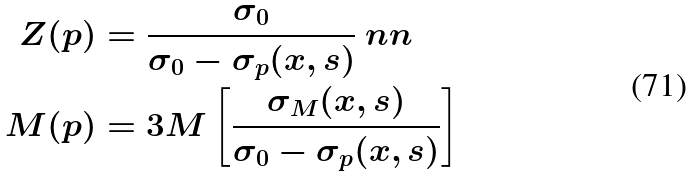<formula> <loc_0><loc_0><loc_500><loc_500>Z ( p ) & = \frac { \sigma _ { 0 } } { \sigma _ { 0 } - \sigma _ { p } ( x , s ) } \ n n \\ M ( p ) & = 3 M \left [ \frac { \sigma _ { M } ( x , s ) } { \sigma _ { 0 } - \sigma _ { p } ( x , s ) } \right ]</formula> 